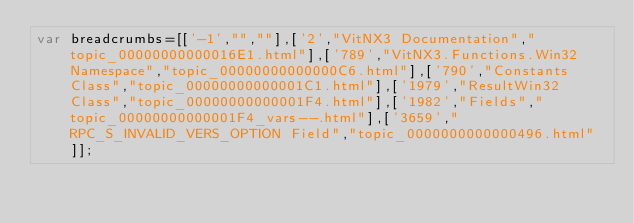<code> <loc_0><loc_0><loc_500><loc_500><_JavaScript_>var breadcrumbs=[['-1',"",""],['2',"VitNX3 Documentation","topic_00000000000016E1.html"],['789',"VitNX3.Functions.Win32 Namespace","topic_00000000000000C6.html"],['790',"Constants Class","topic_00000000000001C1.html"],['1979',"ResultWin32 Class","topic_00000000000001F4.html"],['1982',"Fields","topic_00000000000001F4_vars--.html"],['3659',"RPC_S_INVALID_VERS_OPTION Field","topic_0000000000000496.html"]];</code> 